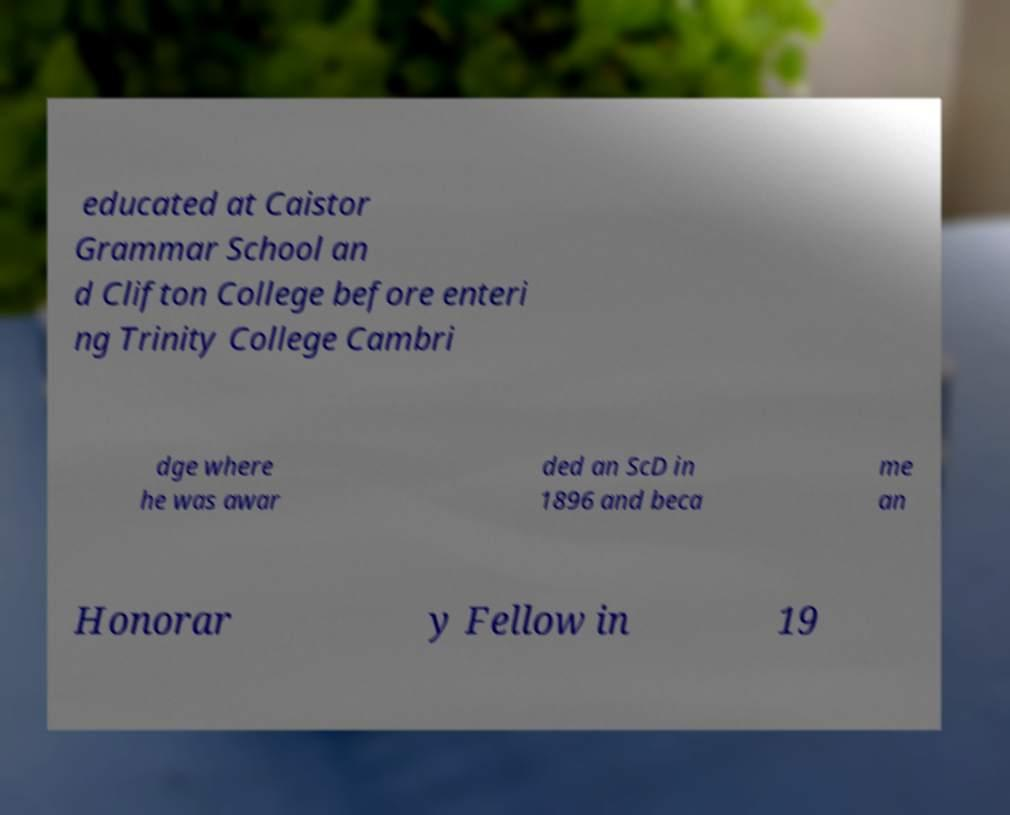Can you accurately transcribe the text from the provided image for me? educated at Caistor Grammar School an d Clifton College before enteri ng Trinity College Cambri dge where he was awar ded an ScD in 1896 and beca me an Honorar y Fellow in 19 